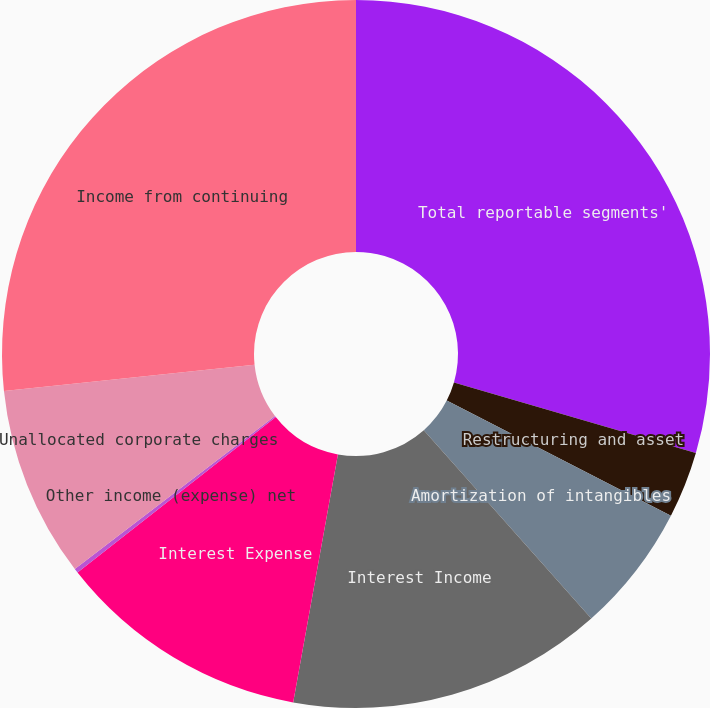Convert chart to OTSL. <chart><loc_0><loc_0><loc_500><loc_500><pie_chart><fcel>Total reportable segments'<fcel>Restructuring and asset<fcel>Amortization of intangibles<fcel>Interest Income<fcel>Interest Expense<fcel>Other income (expense) net<fcel>Unallocated corporate charges<fcel>Income from continuing<nl><fcel>29.51%<fcel>3.04%<fcel>5.88%<fcel>14.41%<fcel>11.57%<fcel>0.2%<fcel>8.72%<fcel>26.67%<nl></chart> 